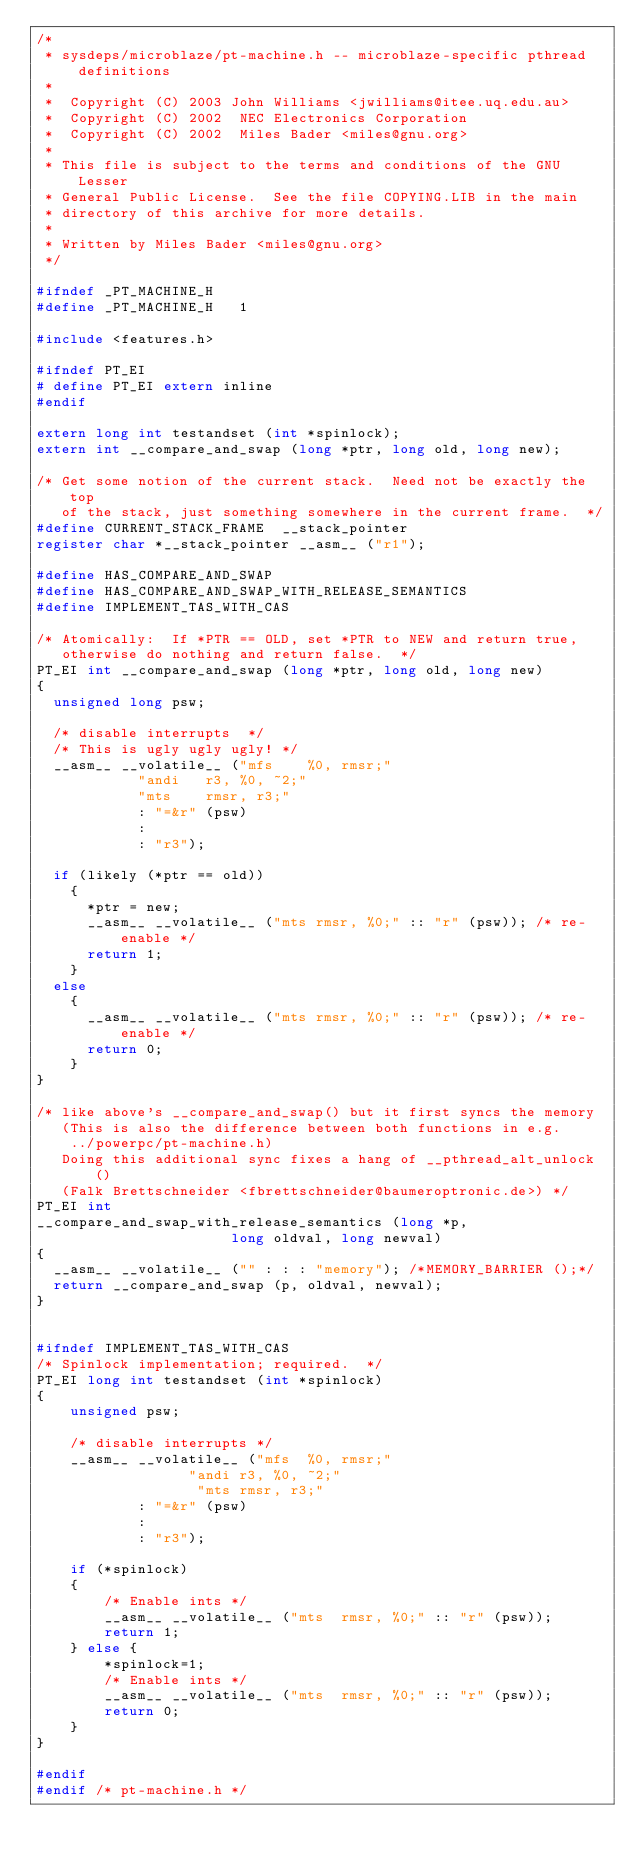<code> <loc_0><loc_0><loc_500><loc_500><_C_>/*
 * sysdeps/microblaze/pt-machine.h -- microblaze-specific pthread definitions
 *
 *  Copyright (C) 2003 John Williams <jwilliams@itee.uq.edu.au>
 *  Copyright (C) 2002  NEC Electronics Corporation
 *  Copyright (C) 2002  Miles Bader <miles@gnu.org>
 *
 * This file is subject to the terms and conditions of the GNU Lesser
 * General Public License.  See the file COPYING.LIB in the main
 * directory of this archive for more details.
 *
 * Written by Miles Bader <miles@gnu.org>
 */

#ifndef _PT_MACHINE_H
#define _PT_MACHINE_H   1

#include <features.h>

#ifndef PT_EI
# define PT_EI extern inline
#endif

extern long int testandset (int *spinlock);
extern int __compare_and_swap (long *ptr, long old, long new);

/* Get some notion of the current stack.  Need not be exactly the top
   of the stack, just something somewhere in the current frame.  */
#define CURRENT_STACK_FRAME  __stack_pointer
register char *__stack_pointer __asm__ ("r1");

#define HAS_COMPARE_AND_SWAP
#define HAS_COMPARE_AND_SWAP_WITH_RELEASE_SEMANTICS
#define IMPLEMENT_TAS_WITH_CAS

/* Atomically:  If *PTR == OLD, set *PTR to NEW and return true,
   otherwise do nothing and return false.  */
PT_EI int __compare_and_swap (long *ptr, long old, long new)
{
  unsigned long psw;

  /* disable interrupts  */
  /* This is ugly ugly ugly! */
  __asm__ __volatile__ ("mfs	%0, rmsr;"
			"andi	r3, %0, ~2;"
			"mts	rmsr, r3;"
			: "=&r" (psw)
			:
			: "r3");

  if (likely (*ptr == old))
    {
      *ptr = new;
      __asm__ __volatile__ ("mts rmsr, %0;" :: "r" (psw)); /* re-enable */
      return 1;
    }
  else
    {
      __asm__ __volatile__ ("mts rmsr, %0;" :: "r" (psw)); /* re-enable */
      return 0;
    }
}

/* like above's __compare_and_swap() but it first syncs the memory
   (This is also the difference between both functions in e.g.
    ../powerpc/pt-machine.h)
   Doing this additional sync fixes a hang of __pthread_alt_unlock()
   (Falk Brettschneider <fbrettschneider@baumeroptronic.de>) */
PT_EI int
__compare_and_swap_with_release_semantics (long *p,
					   long oldval, long newval)
{
  __asm__ __volatile__ ("" : : : "memory"); /*MEMORY_BARRIER ();*/
  return __compare_and_swap (p, oldval, newval);
}


#ifndef IMPLEMENT_TAS_WITH_CAS
/* Spinlock implementation; required.  */
PT_EI long int testandset (int *spinlock)
{
	unsigned psw;

	/* disable interrupts */
	__asm__ __volatile__ ("mfs	%0, rmsr;"
			      "andi	r3, %0, ~2;"
			       "mts	rmsr, r3;"
			: "=&r" (psw)
			:
			: "r3");

	if (*spinlock)
	{
		/* Enable ints */
		__asm__ __volatile__ ("mts	rmsr, %0;" :: "r" (psw));
		return 1;
	} else {
		*spinlock=1;
		/* Enable ints */
		__asm__ __volatile__ ("mts	rmsr, %0;" :: "r" (psw));
		return 0;
	}
}

#endif
#endif /* pt-machine.h */
</code> 